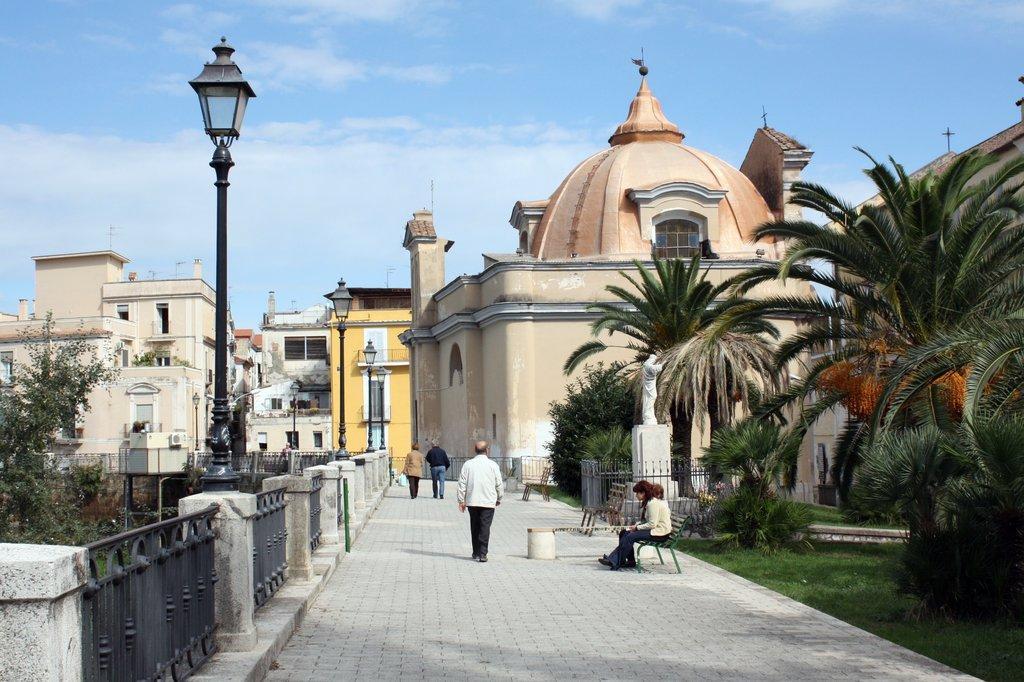How would you summarize this image in a sentence or two? In this image I can see few people with different color dresses. I can see two people sitting on the bench. To the right I can see many trees and railing. To the left I can see the light poles, metal gates and trees. In the background I can see many buildings, clouds and the sky. 